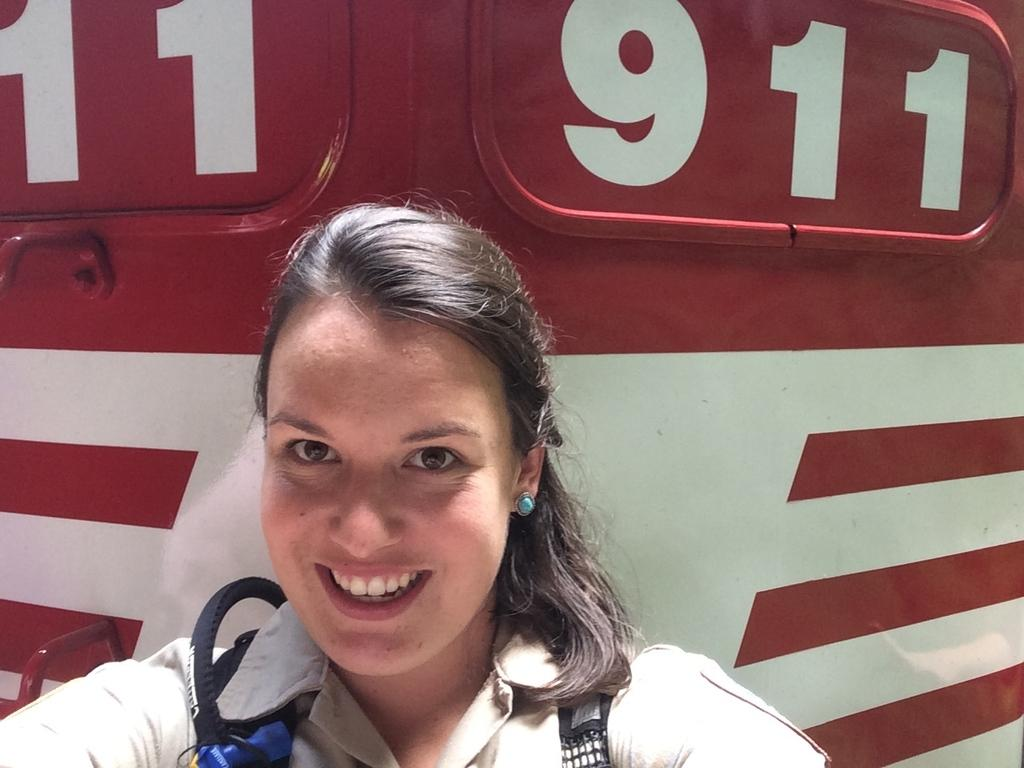Who is present in the image? There is a woman in the image. What is the woman's facial expression? The woman is smiling. Can you describe the background of the image? There is an object in the background of the image. How many mice are visible in the image? There are no mice present in the image. What type of cow can be seen in the background of the image? There is no cow present in the image. 